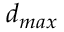<formula> <loc_0><loc_0><loc_500><loc_500>d _ { \max }</formula> 